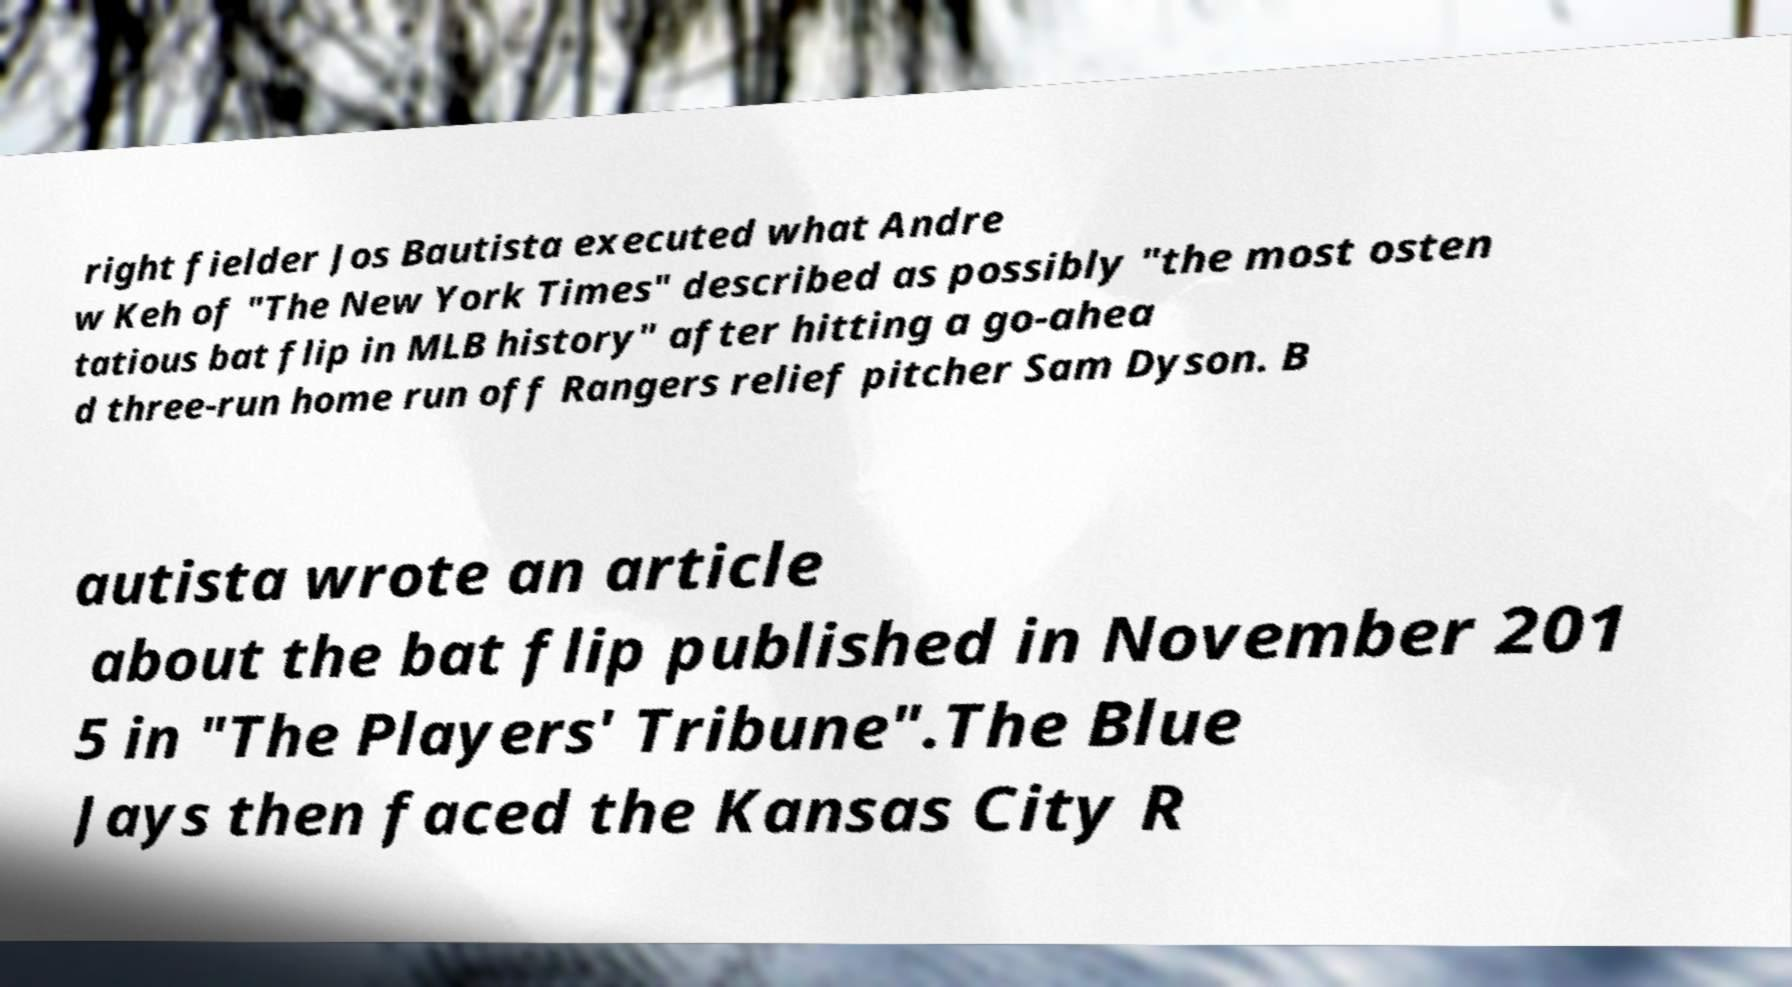Could you extract and type out the text from this image? right fielder Jos Bautista executed what Andre w Keh of "The New York Times" described as possibly "the most osten tatious bat flip in MLB history" after hitting a go-ahea d three-run home run off Rangers relief pitcher Sam Dyson. B autista wrote an article about the bat flip published in November 201 5 in "The Players' Tribune".The Blue Jays then faced the Kansas City R 